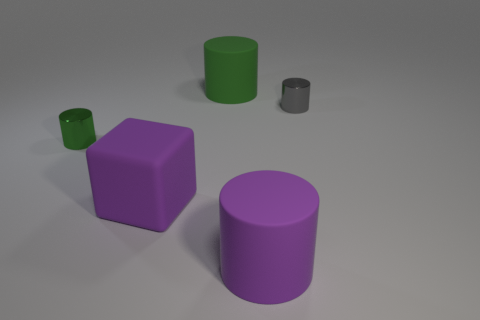Is there a small gray cylinder behind the tiny object behind the green thing to the left of the green rubber cylinder?
Your answer should be very brief. No. There is a big matte cylinder in front of the green metallic thing; is it the same color as the rubber block?
Provide a succinct answer. Yes. How many cylinders are either small gray things or small shiny things?
Your answer should be compact. 2. What is the shape of the purple matte object behind the big purple object that is on the right side of the green rubber cylinder?
Ensure brevity in your answer.  Cube. There is a green thing that is to the right of the metallic object on the left side of the small shiny cylinder behind the small green shiny object; how big is it?
Your response must be concise. Large. Do the green shiny cylinder and the rubber cube have the same size?
Ensure brevity in your answer.  No. How many objects are small things or big purple rubber blocks?
Make the answer very short. 3. What is the size of the rubber cylinder that is behind the tiny green cylinder behind the large purple matte block?
Ensure brevity in your answer.  Large. How big is the green rubber thing?
Ensure brevity in your answer.  Large. There is a thing that is both behind the large rubber cube and in front of the gray object; what is its shape?
Your response must be concise. Cylinder. 